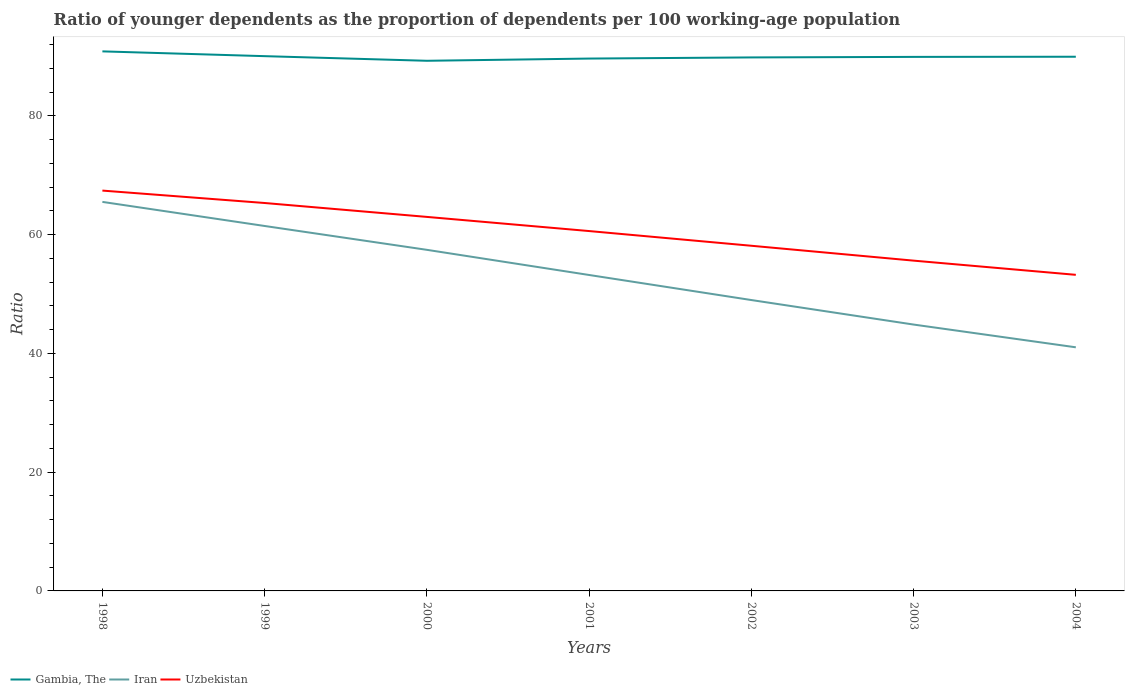Across all years, what is the maximum age dependency ratio(young) in Iran?
Make the answer very short. 41.02. What is the total age dependency ratio(young) in Gambia, The in the graph?
Keep it short and to the point. 0.12. What is the difference between the highest and the second highest age dependency ratio(young) in Gambia, The?
Provide a short and direct response. 1.59. What is the difference between the highest and the lowest age dependency ratio(young) in Iran?
Ensure brevity in your answer.  3. Is the age dependency ratio(young) in Gambia, The strictly greater than the age dependency ratio(young) in Iran over the years?
Your answer should be compact. No. How many lines are there?
Your answer should be very brief. 3. Are the values on the major ticks of Y-axis written in scientific E-notation?
Provide a short and direct response. No. Does the graph contain any zero values?
Provide a short and direct response. No. Does the graph contain grids?
Offer a very short reply. No. Where does the legend appear in the graph?
Your response must be concise. Bottom left. How are the legend labels stacked?
Your response must be concise. Horizontal. What is the title of the graph?
Provide a succinct answer. Ratio of younger dependents as the proportion of dependents per 100 working-age population. Does "Korea (Democratic)" appear as one of the legend labels in the graph?
Offer a very short reply. No. What is the label or title of the Y-axis?
Offer a terse response. Ratio. What is the Ratio in Gambia, The in 1998?
Keep it short and to the point. 90.85. What is the Ratio in Iran in 1998?
Provide a short and direct response. 65.51. What is the Ratio of Uzbekistan in 1998?
Offer a terse response. 67.41. What is the Ratio of Gambia, The in 1999?
Provide a short and direct response. 90.05. What is the Ratio of Iran in 1999?
Your answer should be compact. 61.45. What is the Ratio in Uzbekistan in 1999?
Keep it short and to the point. 65.32. What is the Ratio in Gambia, The in 2000?
Your answer should be very brief. 89.27. What is the Ratio in Iran in 2000?
Your answer should be compact. 57.44. What is the Ratio in Uzbekistan in 2000?
Your response must be concise. 62.98. What is the Ratio of Gambia, The in 2001?
Provide a short and direct response. 89.64. What is the Ratio in Iran in 2001?
Provide a succinct answer. 53.2. What is the Ratio in Uzbekistan in 2001?
Make the answer very short. 60.6. What is the Ratio in Gambia, The in 2002?
Make the answer very short. 89.84. What is the Ratio of Iran in 2002?
Ensure brevity in your answer.  48.98. What is the Ratio of Uzbekistan in 2002?
Give a very brief answer. 58.12. What is the Ratio of Gambia, The in 2003?
Give a very brief answer. 89.92. What is the Ratio of Iran in 2003?
Keep it short and to the point. 44.85. What is the Ratio of Uzbekistan in 2003?
Give a very brief answer. 55.62. What is the Ratio in Gambia, The in 2004?
Make the answer very short. 89.95. What is the Ratio of Iran in 2004?
Keep it short and to the point. 41.02. What is the Ratio in Uzbekistan in 2004?
Your response must be concise. 53.23. Across all years, what is the maximum Ratio in Gambia, The?
Make the answer very short. 90.85. Across all years, what is the maximum Ratio in Iran?
Offer a terse response. 65.51. Across all years, what is the maximum Ratio in Uzbekistan?
Make the answer very short. 67.41. Across all years, what is the minimum Ratio in Gambia, The?
Make the answer very short. 89.27. Across all years, what is the minimum Ratio of Iran?
Your response must be concise. 41.02. Across all years, what is the minimum Ratio of Uzbekistan?
Provide a succinct answer. 53.23. What is the total Ratio of Gambia, The in the graph?
Ensure brevity in your answer.  629.52. What is the total Ratio of Iran in the graph?
Your answer should be compact. 372.45. What is the total Ratio in Uzbekistan in the graph?
Offer a very short reply. 423.27. What is the difference between the Ratio in Gambia, The in 1998 and that in 1999?
Provide a short and direct response. 0.8. What is the difference between the Ratio in Iran in 1998 and that in 1999?
Your answer should be very brief. 4.06. What is the difference between the Ratio of Uzbekistan in 1998 and that in 1999?
Ensure brevity in your answer.  2.09. What is the difference between the Ratio of Gambia, The in 1998 and that in 2000?
Keep it short and to the point. 1.59. What is the difference between the Ratio in Iran in 1998 and that in 2000?
Provide a short and direct response. 8.07. What is the difference between the Ratio of Uzbekistan in 1998 and that in 2000?
Ensure brevity in your answer.  4.43. What is the difference between the Ratio in Gambia, The in 1998 and that in 2001?
Provide a short and direct response. 1.21. What is the difference between the Ratio of Iran in 1998 and that in 2001?
Your answer should be very brief. 12.31. What is the difference between the Ratio of Uzbekistan in 1998 and that in 2001?
Provide a succinct answer. 6.81. What is the difference between the Ratio of Gambia, The in 1998 and that in 2002?
Your response must be concise. 1.02. What is the difference between the Ratio in Iran in 1998 and that in 2002?
Offer a terse response. 16.53. What is the difference between the Ratio of Uzbekistan in 1998 and that in 2002?
Give a very brief answer. 9.29. What is the difference between the Ratio in Gambia, The in 1998 and that in 2003?
Keep it short and to the point. 0.93. What is the difference between the Ratio in Iran in 1998 and that in 2003?
Your answer should be compact. 20.66. What is the difference between the Ratio of Uzbekistan in 1998 and that in 2003?
Offer a terse response. 11.8. What is the difference between the Ratio of Gambia, The in 1998 and that in 2004?
Offer a very short reply. 0.9. What is the difference between the Ratio in Iran in 1998 and that in 2004?
Your answer should be very brief. 24.49. What is the difference between the Ratio in Uzbekistan in 1998 and that in 2004?
Make the answer very short. 14.19. What is the difference between the Ratio in Gambia, The in 1999 and that in 2000?
Your answer should be very brief. 0.78. What is the difference between the Ratio in Iran in 1999 and that in 2000?
Your answer should be very brief. 4.02. What is the difference between the Ratio in Uzbekistan in 1999 and that in 2000?
Give a very brief answer. 2.34. What is the difference between the Ratio in Gambia, The in 1999 and that in 2001?
Your response must be concise. 0.41. What is the difference between the Ratio of Iran in 1999 and that in 2001?
Offer a terse response. 8.25. What is the difference between the Ratio of Uzbekistan in 1999 and that in 2001?
Give a very brief answer. 4.72. What is the difference between the Ratio of Gambia, The in 1999 and that in 2002?
Keep it short and to the point. 0.21. What is the difference between the Ratio of Iran in 1999 and that in 2002?
Keep it short and to the point. 12.47. What is the difference between the Ratio in Uzbekistan in 1999 and that in 2002?
Provide a succinct answer. 7.2. What is the difference between the Ratio in Gambia, The in 1999 and that in 2003?
Keep it short and to the point. 0.12. What is the difference between the Ratio in Iran in 1999 and that in 2003?
Provide a short and direct response. 16.6. What is the difference between the Ratio of Uzbekistan in 1999 and that in 2003?
Offer a terse response. 9.7. What is the difference between the Ratio in Gambia, The in 1999 and that in 2004?
Offer a very short reply. 0.1. What is the difference between the Ratio in Iran in 1999 and that in 2004?
Offer a terse response. 20.43. What is the difference between the Ratio of Uzbekistan in 1999 and that in 2004?
Your answer should be very brief. 12.1. What is the difference between the Ratio of Gambia, The in 2000 and that in 2001?
Make the answer very short. -0.38. What is the difference between the Ratio of Iran in 2000 and that in 2001?
Make the answer very short. 4.24. What is the difference between the Ratio of Uzbekistan in 2000 and that in 2001?
Your response must be concise. 2.38. What is the difference between the Ratio of Gambia, The in 2000 and that in 2002?
Make the answer very short. -0.57. What is the difference between the Ratio of Iran in 2000 and that in 2002?
Provide a short and direct response. 8.45. What is the difference between the Ratio in Uzbekistan in 2000 and that in 2002?
Provide a succinct answer. 4.86. What is the difference between the Ratio in Gambia, The in 2000 and that in 2003?
Offer a very short reply. -0.66. What is the difference between the Ratio in Iran in 2000 and that in 2003?
Keep it short and to the point. 12.58. What is the difference between the Ratio of Uzbekistan in 2000 and that in 2003?
Your answer should be compact. 7.36. What is the difference between the Ratio in Gambia, The in 2000 and that in 2004?
Your answer should be very brief. -0.68. What is the difference between the Ratio in Iran in 2000 and that in 2004?
Your response must be concise. 16.41. What is the difference between the Ratio of Uzbekistan in 2000 and that in 2004?
Provide a succinct answer. 9.75. What is the difference between the Ratio of Gambia, The in 2001 and that in 2002?
Offer a terse response. -0.19. What is the difference between the Ratio of Iran in 2001 and that in 2002?
Ensure brevity in your answer.  4.22. What is the difference between the Ratio in Uzbekistan in 2001 and that in 2002?
Provide a short and direct response. 2.48. What is the difference between the Ratio of Gambia, The in 2001 and that in 2003?
Offer a very short reply. -0.28. What is the difference between the Ratio of Iran in 2001 and that in 2003?
Ensure brevity in your answer.  8.35. What is the difference between the Ratio of Uzbekistan in 2001 and that in 2003?
Offer a very short reply. 4.98. What is the difference between the Ratio in Gambia, The in 2001 and that in 2004?
Ensure brevity in your answer.  -0.31. What is the difference between the Ratio of Iran in 2001 and that in 2004?
Provide a short and direct response. 12.18. What is the difference between the Ratio of Uzbekistan in 2001 and that in 2004?
Your response must be concise. 7.37. What is the difference between the Ratio of Gambia, The in 2002 and that in 2003?
Keep it short and to the point. -0.09. What is the difference between the Ratio in Iran in 2002 and that in 2003?
Your answer should be very brief. 4.13. What is the difference between the Ratio in Uzbekistan in 2002 and that in 2003?
Give a very brief answer. 2.51. What is the difference between the Ratio of Gambia, The in 2002 and that in 2004?
Your answer should be very brief. -0.12. What is the difference between the Ratio of Iran in 2002 and that in 2004?
Ensure brevity in your answer.  7.96. What is the difference between the Ratio in Uzbekistan in 2002 and that in 2004?
Your answer should be very brief. 4.9. What is the difference between the Ratio in Gambia, The in 2003 and that in 2004?
Your answer should be compact. -0.03. What is the difference between the Ratio of Iran in 2003 and that in 2004?
Offer a terse response. 3.83. What is the difference between the Ratio in Uzbekistan in 2003 and that in 2004?
Ensure brevity in your answer.  2.39. What is the difference between the Ratio of Gambia, The in 1998 and the Ratio of Iran in 1999?
Make the answer very short. 29.4. What is the difference between the Ratio in Gambia, The in 1998 and the Ratio in Uzbekistan in 1999?
Offer a very short reply. 25.53. What is the difference between the Ratio in Iran in 1998 and the Ratio in Uzbekistan in 1999?
Provide a short and direct response. 0.19. What is the difference between the Ratio of Gambia, The in 1998 and the Ratio of Iran in 2000?
Give a very brief answer. 33.42. What is the difference between the Ratio in Gambia, The in 1998 and the Ratio in Uzbekistan in 2000?
Offer a terse response. 27.87. What is the difference between the Ratio in Iran in 1998 and the Ratio in Uzbekistan in 2000?
Your answer should be very brief. 2.53. What is the difference between the Ratio of Gambia, The in 1998 and the Ratio of Iran in 2001?
Keep it short and to the point. 37.65. What is the difference between the Ratio in Gambia, The in 1998 and the Ratio in Uzbekistan in 2001?
Your response must be concise. 30.26. What is the difference between the Ratio in Iran in 1998 and the Ratio in Uzbekistan in 2001?
Give a very brief answer. 4.91. What is the difference between the Ratio in Gambia, The in 1998 and the Ratio in Iran in 2002?
Give a very brief answer. 41.87. What is the difference between the Ratio of Gambia, The in 1998 and the Ratio of Uzbekistan in 2002?
Offer a terse response. 32.73. What is the difference between the Ratio in Iran in 1998 and the Ratio in Uzbekistan in 2002?
Your response must be concise. 7.39. What is the difference between the Ratio of Gambia, The in 1998 and the Ratio of Iran in 2003?
Your answer should be compact. 46. What is the difference between the Ratio in Gambia, The in 1998 and the Ratio in Uzbekistan in 2003?
Provide a succinct answer. 35.24. What is the difference between the Ratio in Iran in 1998 and the Ratio in Uzbekistan in 2003?
Ensure brevity in your answer.  9.89. What is the difference between the Ratio of Gambia, The in 1998 and the Ratio of Iran in 2004?
Provide a short and direct response. 49.83. What is the difference between the Ratio of Gambia, The in 1998 and the Ratio of Uzbekistan in 2004?
Your answer should be very brief. 37.63. What is the difference between the Ratio in Iran in 1998 and the Ratio in Uzbekistan in 2004?
Offer a very short reply. 12.28. What is the difference between the Ratio of Gambia, The in 1999 and the Ratio of Iran in 2000?
Keep it short and to the point. 32.61. What is the difference between the Ratio in Gambia, The in 1999 and the Ratio in Uzbekistan in 2000?
Provide a short and direct response. 27.07. What is the difference between the Ratio of Iran in 1999 and the Ratio of Uzbekistan in 2000?
Your answer should be very brief. -1.53. What is the difference between the Ratio in Gambia, The in 1999 and the Ratio in Iran in 2001?
Your answer should be compact. 36.85. What is the difference between the Ratio of Gambia, The in 1999 and the Ratio of Uzbekistan in 2001?
Offer a very short reply. 29.45. What is the difference between the Ratio in Iran in 1999 and the Ratio in Uzbekistan in 2001?
Your response must be concise. 0.85. What is the difference between the Ratio in Gambia, The in 1999 and the Ratio in Iran in 2002?
Provide a short and direct response. 41.07. What is the difference between the Ratio of Gambia, The in 1999 and the Ratio of Uzbekistan in 2002?
Make the answer very short. 31.93. What is the difference between the Ratio in Iran in 1999 and the Ratio in Uzbekistan in 2002?
Make the answer very short. 3.33. What is the difference between the Ratio of Gambia, The in 1999 and the Ratio of Iran in 2003?
Your response must be concise. 45.2. What is the difference between the Ratio in Gambia, The in 1999 and the Ratio in Uzbekistan in 2003?
Provide a succinct answer. 34.43. What is the difference between the Ratio of Iran in 1999 and the Ratio of Uzbekistan in 2003?
Your answer should be compact. 5.84. What is the difference between the Ratio in Gambia, The in 1999 and the Ratio in Iran in 2004?
Provide a short and direct response. 49.03. What is the difference between the Ratio of Gambia, The in 1999 and the Ratio of Uzbekistan in 2004?
Your answer should be compact. 36.82. What is the difference between the Ratio of Iran in 1999 and the Ratio of Uzbekistan in 2004?
Keep it short and to the point. 8.23. What is the difference between the Ratio in Gambia, The in 2000 and the Ratio in Iran in 2001?
Provide a short and direct response. 36.07. What is the difference between the Ratio of Gambia, The in 2000 and the Ratio of Uzbekistan in 2001?
Offer a terse response. 28.67. What is the difference between the Ratio of Iran in 2000 and the Ratio of Uzbekistan in 2001?
Offer a terse response. -3.16. What is the difference between the Ratio in Gambia, The in 2000 and the Ratio in Iran in 2002?
Give a very brief answer. 40.29. What is the difference between the Ratio of Gambia, The in 2000 and the Ratio of Uzbekistan in 2002?
Your response must be concise. 31.15. What is the difference between the Ratio in Iran in 2000 and the Ratio in Uzbekistan in 2002?
Offer a very short reply. -0.69. What is the difference between the Ratio in Gambia, The in 2000 and the Ratio in Iran in 2003?
Give a very brief answer. 44.41. What is the difference between the Ratio of Gambia, The in 2000 and the Ratio of Uzbekistan in 2003?
Make the answer very short. 33.65. What is the difference between the Ratio in Iran in 2000 and the Ratio in Uzbekistan in 2003?
Your answer should be very brief. 1.82. What is the difference between the Ratio of Gambia, The in 2000 and the Ratio of Iran in 2004?
Offer a terse response. 48.25. What is the difference between the Ratio of Gambia, The in 2000 and the Ratio of Uzbekistan in 2004?
Your response must be concise. 36.04. What is the difference between the Ratio in Iran in 2000 and the Ratio in Uzbekistan in 2004?
Your answer should be compact. 4.21. What is the difference between the Ratio in Gambia, The in 2001 and the Ratio in Iran in 2002?
Offer a terse response. 40.66. What is the difference between the Ratio in Gambia, The in 2001 and the Ratio in Uzbekistan in 2002?
Keep it short and to the point. 31.52. What is the difference between the Ratio of Iran in 2001 and the Ratio of Uzbekistan in 2002?
Provide a short and direct response. -4.92. What is the difference between the Ratio in Gambia, The in 2001 and the Ratio in Iran in 2003?
Make the answer very short. 44.79. What is the difference between the Ratio of Gambia, The in 2001 and the Ratio of Uzbekistan in 2003?
Keep it short and to the point. 34.03. What is the difference between the Ratio of Iran in 2001 and the Ratio of Uzbekistan in 2003?
Your answer should be very brief. -2.42. What is the difference between the Ratio in Gambia, The in 2001 and the Ratio in Iran in 2004?
Ensure brevity in your answer.  48.62. What is the difference between the Ratio in Gambia, The in 2001 and the Ratio in Uzbekistan in 2004?
Provide a succinct answer. 36.42. What is the difference between the Ratio of Iran in 2001 and the Ratio of Uzbekistan in 2004?
Your answer should be compact. -0.03. What is the difference between the Ratio in Gambia, The in 2002 and the Ratio in Iran in 2003?
Your response must be concise. 44.98. What is the difference between the Ratio in Gambia, The in 2002 and the Ratio in Uzbekistan in 2003?
Keep it short and to the point. 34.22. What is the difference between the Ratio of Iran in 2002 and the Ratio of Uzbekistan in 2003?
Your answer should be very brief. -6.63. What is the difference between the Ratio of Gambia, The in 2002 and the Ratio of Iran in 2004?
Make the answer very short. 48.81. What is the difference between the Ratio of Gambia, The in 2002 and the Ratio of Uzbekistan in 2004?
Make the answer very short. 36.61. What is the difference between the Ratio of Iran in 2002 and the Ratio of Uzbekistan in 2004?
Provide a short and direct response. -4.24. What is the difference between the Ratio of Gambia, The in 2003 and the Ratio of Iran in 2004?
Your answer should be very brief. 48.9. What is the difference between the Ratio of Gambia, The in 2003 and the Ratio of Uzbekistan in 2004?
Provide a short and direct response. 36.7. What is the difference between the Ratio of Iran in 2003 and the Ratio of Uzbekistan in 2004?
Your answer should be compact. -8.37. What is the average Ratio in Gambia, The per year?
Keep it short and to the point. 89.93. What is the average Ratio in Iran per year?
Your response must be concise. 53.21. What is the average Ratio of Uzbekistan per year?
Provide a short and direct response. 60.47. In the year 1998, what is the difference between the Ratio in Gambia, The and Ratio in Iran?
Ensure brevity in your answer.  25.35. In the year 1998, what is the difference between the Ratio in Gambia, The and Ratio in Uzbekistan?
Provide a short and direct response. 23.44. In the year 1998, what is the difference between the Ratio of Iran and Ratio of Uzbekistan?
Your answer should be compact. -1.9. In the year 1999, what is the difference between the Ratio of Gambia, The and Ratio of Iran?
Offer a terse response. 28.6. In the year 1999, what is the difference between the Ratio of Gambia, The and Ratio of Uzbekistan?
Make the answer very short. 24.73. In the year 1999, what is the difference between the Ratio in Iran and Ratio in Uzbekistan?
Ensure brevity in your answer.  -3.87. In the year 2000, what is the difference between the Ratio of Gambia, The and Ratio of Iran?
Offer a terse response. 31.83. In the year 2000, what is the difference between the Ratio in Gambia, The and Ratio in Uzbekistan?
Make the answer very short. 26.29. In the year 2000, what is the difference between the Ratio in Iran and Ratio in Uzbekistan?
Ensure brevity in your answer.  -5.54. In the year 2001, what is the difference between the Ratio of Gambia, The and Ratio of Iran?
Provide a succinct answer. 36.44. In the year 2001, what is the difference between the Ratio in Gambia, The and Ratio in Uzbekistan?
Your answer should be compact. 29.05. In the year 2001, what is the difference between the Ratio in Iran and Ratio in Uzbekistan?
Keep it short and to the point. -7.4. In the year 2002, what is the difference between the Ratio of Gambia, The and Ratio of Iran?
Ensure brevity in your answer.  40.85. In the year 2002, what is the difference between the Ratio of Gambia, The and Ratio of Uzbekistan?
Make the answer very short. 31.71. In the year 2002, what is the difference between the Ratio of Iran and Ratio of Uzbekistan?
Make the answer very short. -9.14. In the year 2003, what is the difference between the Ratio of Gambia, The and Ratio of Iran?
Offer a very short reply. 45.07. In the year 2003, what is the difference between the Ratio in Gambia, The and Ratio in Uzbekistan?
Your answer should be very brief. 34.31. In the year 2003, what is the difference between the Ratio in Iran and Ratio in Uzbekistan?
Keep it short and to the point. -10.76. In the year 2004, what is the difference between the Ratio in Gambia, The and Ratio in Iran?
Your answer should be compact. 48.93. In the year 2004, what is the difference between the Ratio of Gambia, The and Ratio of Uzbekistan?
Provide a short and direct response. 36.73. In the year 2004, what is the difference between the Ratio of Iran and Ratio of Uzbekistan?
Provide a short and direct response. -12.2. What is the ratio of the Ratio of Gambia, The in 1998 to that in 1999?
Offer a terse response. 1.01. What is the ratio of the Ratio in Iran in 1998 to that in 1999?
Make the answer very short. 1.07. What is the ratio of the Ratio of Uzbekistan in 1998 to that in 1999?
Provide a succinct answer. 1.03. What is the ratio of the Ratio of Gambia, The in 1998 to that in 2000?
Give a very brief answer. 1.02. What is the ratio of the Ratio in Iran in 1998 to that in 2000?
Provide a short and direct response. 1.14. What is the ratio of the Ratio of Uzbekistan in 1998 to that in 2000?
Your response must be concise. 1.07. What is the ratio of the Ratio of Gambia, The in 1998 to that in 2001?
Make the answer very short. 1.01. What is the ratio of the Ratio of Iran in 1998 to that in 2001?
Ensure brevity in your answer.  1.23. What is the ratio of the Ratio of Uzbekistan in 1998 to that in 2001?
Give a very brief answer. 1.11. What is the ratio of the Ratio in Gambia, The in 1998 to that in 2002?
Keep it short and to the point. 1.01. What is the ratio of the Ratio in Iran in 1998 to that in 2002?
Offer a terse response. 1.34. What is the ratio of the Ratio of Uzbekistan in 1998 to that in 2002?
Your answer should be compact. 1.16. What is the ratio of the Ratio of Gambia, The in 1998 to that in 2003?
Provide a succinct answer. 1.01. What is the ratio of the Ratio in Iran in 1998 to that in 2003?
Your response must be concise. 1.46. What is the ratio of the Ratio in Uzbekistan in 1998 to that in 2003?
Your response must be concise. 1.21. What is the ratio of the Ratio of Gambia, The in 1998 to that in 2004?
Give a very brief answer. 1.01. What is the ratio of the Ratio of Iran in 1998 to that in 2004?
Your response must be concise. 1.6. What is the ratio of the Ratio in Uzbekistan in 1998 to that in 2004?
Your answer should be compact. 1.27. What is the ratio of the Ratio of Gambia, The in 1999 to that in 2000?
Provide a short and direct response. 1.01. What is the ratio of the Ratio of Iran in 1999 to that in 2000?
Your answer should be very brief. 1.07. What is the ratio of the Ratio in Uzbekistan in 1999 to that in 2000?
Ensure brevity in your answer.  1.04. What is the ratio of the Ratio in Iran in 1999 to that in 2001?
Ensure brevity in your answer.  1.16. What is the ratio of the Ratio in Uzbekistan in 1999 to that in 2001?
Offer a very short reply. 1.08. What is the ratio of the Ratio of Iran in 1999 to that in 2002?
Provide a succinct answer. 1.25. What is the ratio of the Ratio of Uzbekistan in 1999 to that in 2002?
Offer a very short reply. 1.12. What is the ratio of the Ratio in Gambia, The in 1999 to that in 2003?
Offer a very short reply. 1. What is the ratio of the Ratio of Iran in 1999 to that in 2003?
Give a very brief answer. 1.37. What is the ratio of the Ratio in Uzbekistan in 1999 to that in 2003?
Your answer should be compact. 1.17. What is the ratio of the Ratio in Iran in 1999 to that in 2004?
Give a very brief answer. 1.5. What is the ratio of the Ratio of Uzbekistan in 1999 to that in 2004?
Your response must be concise. 1.23. What is the ratio of the Ratio in Iran in 2000 to that in 2001?
Offer a terse response. 1.08. What is the ratio of the Ratio in Uzbekistan in 2000 to that in 2001?
Offer a terse response. 1.04. What is the ratio of the Ratio in Iran in 2000 to that in 2002?
Provide a succinct answer. 1.17. What is the ratio of the Ratio in Uzbekistan in 2000 to that in 2002?
Give a very brief answer. 1.08. What is the ratio of the Ratio in Gambia, The in 2000 to that in 2003?
Make the answer very short. 0.99. What is the ratio of the Ratio in Iran in 2000 to that in 2003?
Ensure brevity in your answer.  1.28. What is the ratio of the Ratio of Uzbekistan in 2000 to that in 2003?
Provide a succinct answer. 1.13. What is the ratio of the Ratio in Gambia, The in 2000 to that in 2004?
Provide a succinct answer. 0.99. What is the ratio of the Ratio in Iran in 2000 to that in 2004?
Keep it short and to the point. 1.4. What is the ratio of the Ratio in Uzbekistan in 2000 to that in 2004?
Keep it short and to the point. 1.18. What is the ratio of the Ratio in Iran in 2001 to that in 2002?
Make the answer very short. 1.09. What is the ratio of the Ratio of Uzbekistan in 2001 to that in 2002?
Your answer should be very brief. 1.04. What is the ratio of the Ratio of Iran in 2001 to that in 2003?
Your answer should be very brief. 1.19. What is the ratio of the Ratio of Uzbekistan in 2001 to that in 2003?
Your answer should be very brief. 1.09. What is the ratio of the Ratio in Iran in 2001 to that in 2004?
Keep it short and to the point. 1.3. What is the ratio of the Ratio of Uzbekistan in 2001 to that in 2004?
Your answer should be very brief. 1.14. What is the ratio of the Ratio in Gambia, The in 2002 to that in 2003?
Your answer should be compact. 1. What is the ratio of the Ratio in Iran in 2002 to that in 2003?
Provide a short and direct response. 1.09. What is the ratio of the Ratio of Uzbekistan in 2002 to that in 2003?
Ensure brevity in your answer.  1.04. What is the ratio of the Ratio in Iran in 2002 to that in 2004?
Give a very brief answer. 1.19. What is the ratio of the Ratio in Uzbekistan in 2002 to that in 2004?
Make the answer very short. 1.09. What is the ratio of the Ratio in Gambia, The in 2003 to that in 2004?
Offer a very short reply. 1. What is the ratio of the Ratio of Iran in 2003 to that in 2004?
Give a very brief answer. 1.09. What is the ratio of the Ratio in Uzbekistan in 2003 to that in 2004?
Offer a very short reply. 1.04. What is the difference between the highest and the second highest Ratio of Gambia, The?
Provide a short and direct response. 0.8. What is the difference between the highest and the second highest Ratio of Iran?
Ensure brevity in your answer.  4.06. What is the difference between the highest and the second highest Ratio in Uzbekistan?
Your answer should be compact. 2.09. What is the difference between the highest and the lowest Ratio in Gambia, The?
Provide a succinct answer. 1.59. What is the difference between the highest and the lowest Ratio of Iran?
Keep it short and to the point. 24.49. What is the difference between the highest and the lowest Ratio of Uzbekistan?
Provide a short and direct response. 14.19. 